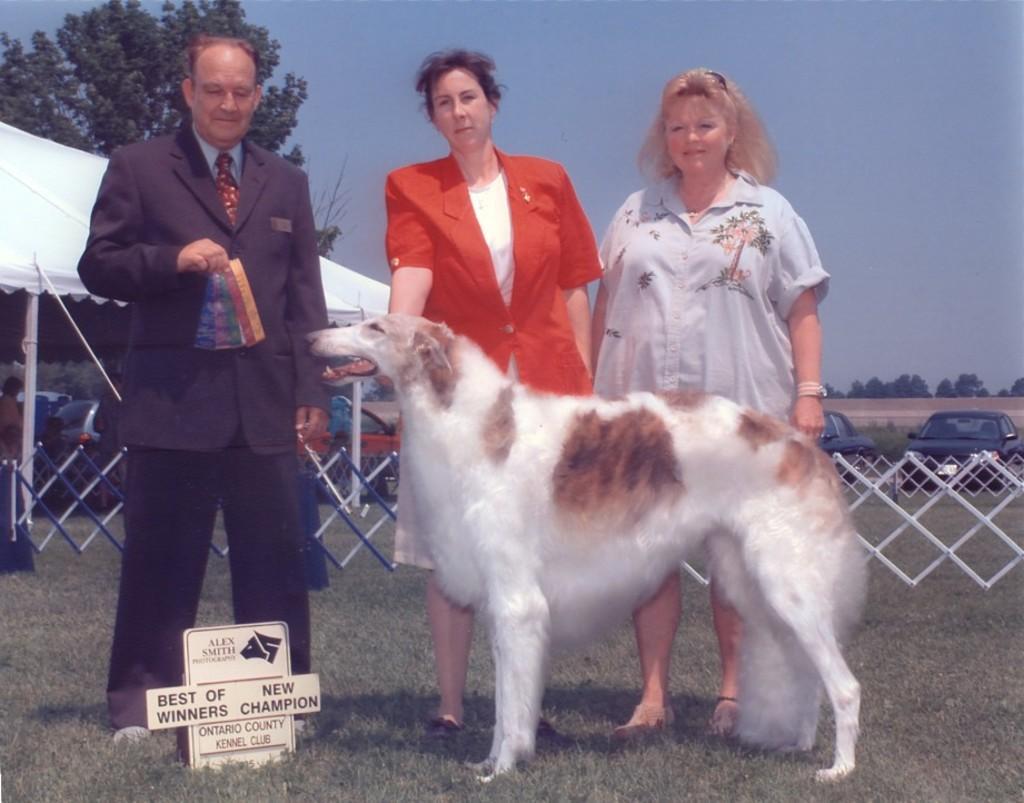Describe this image in one or two sentences. There are three people standing. This is a dog. I can see a board, which is on the grass. I think these are the fences. This looks like a tent. I can see a tree. In the background, I think these are the cars, which are parked. Here is the sky. 